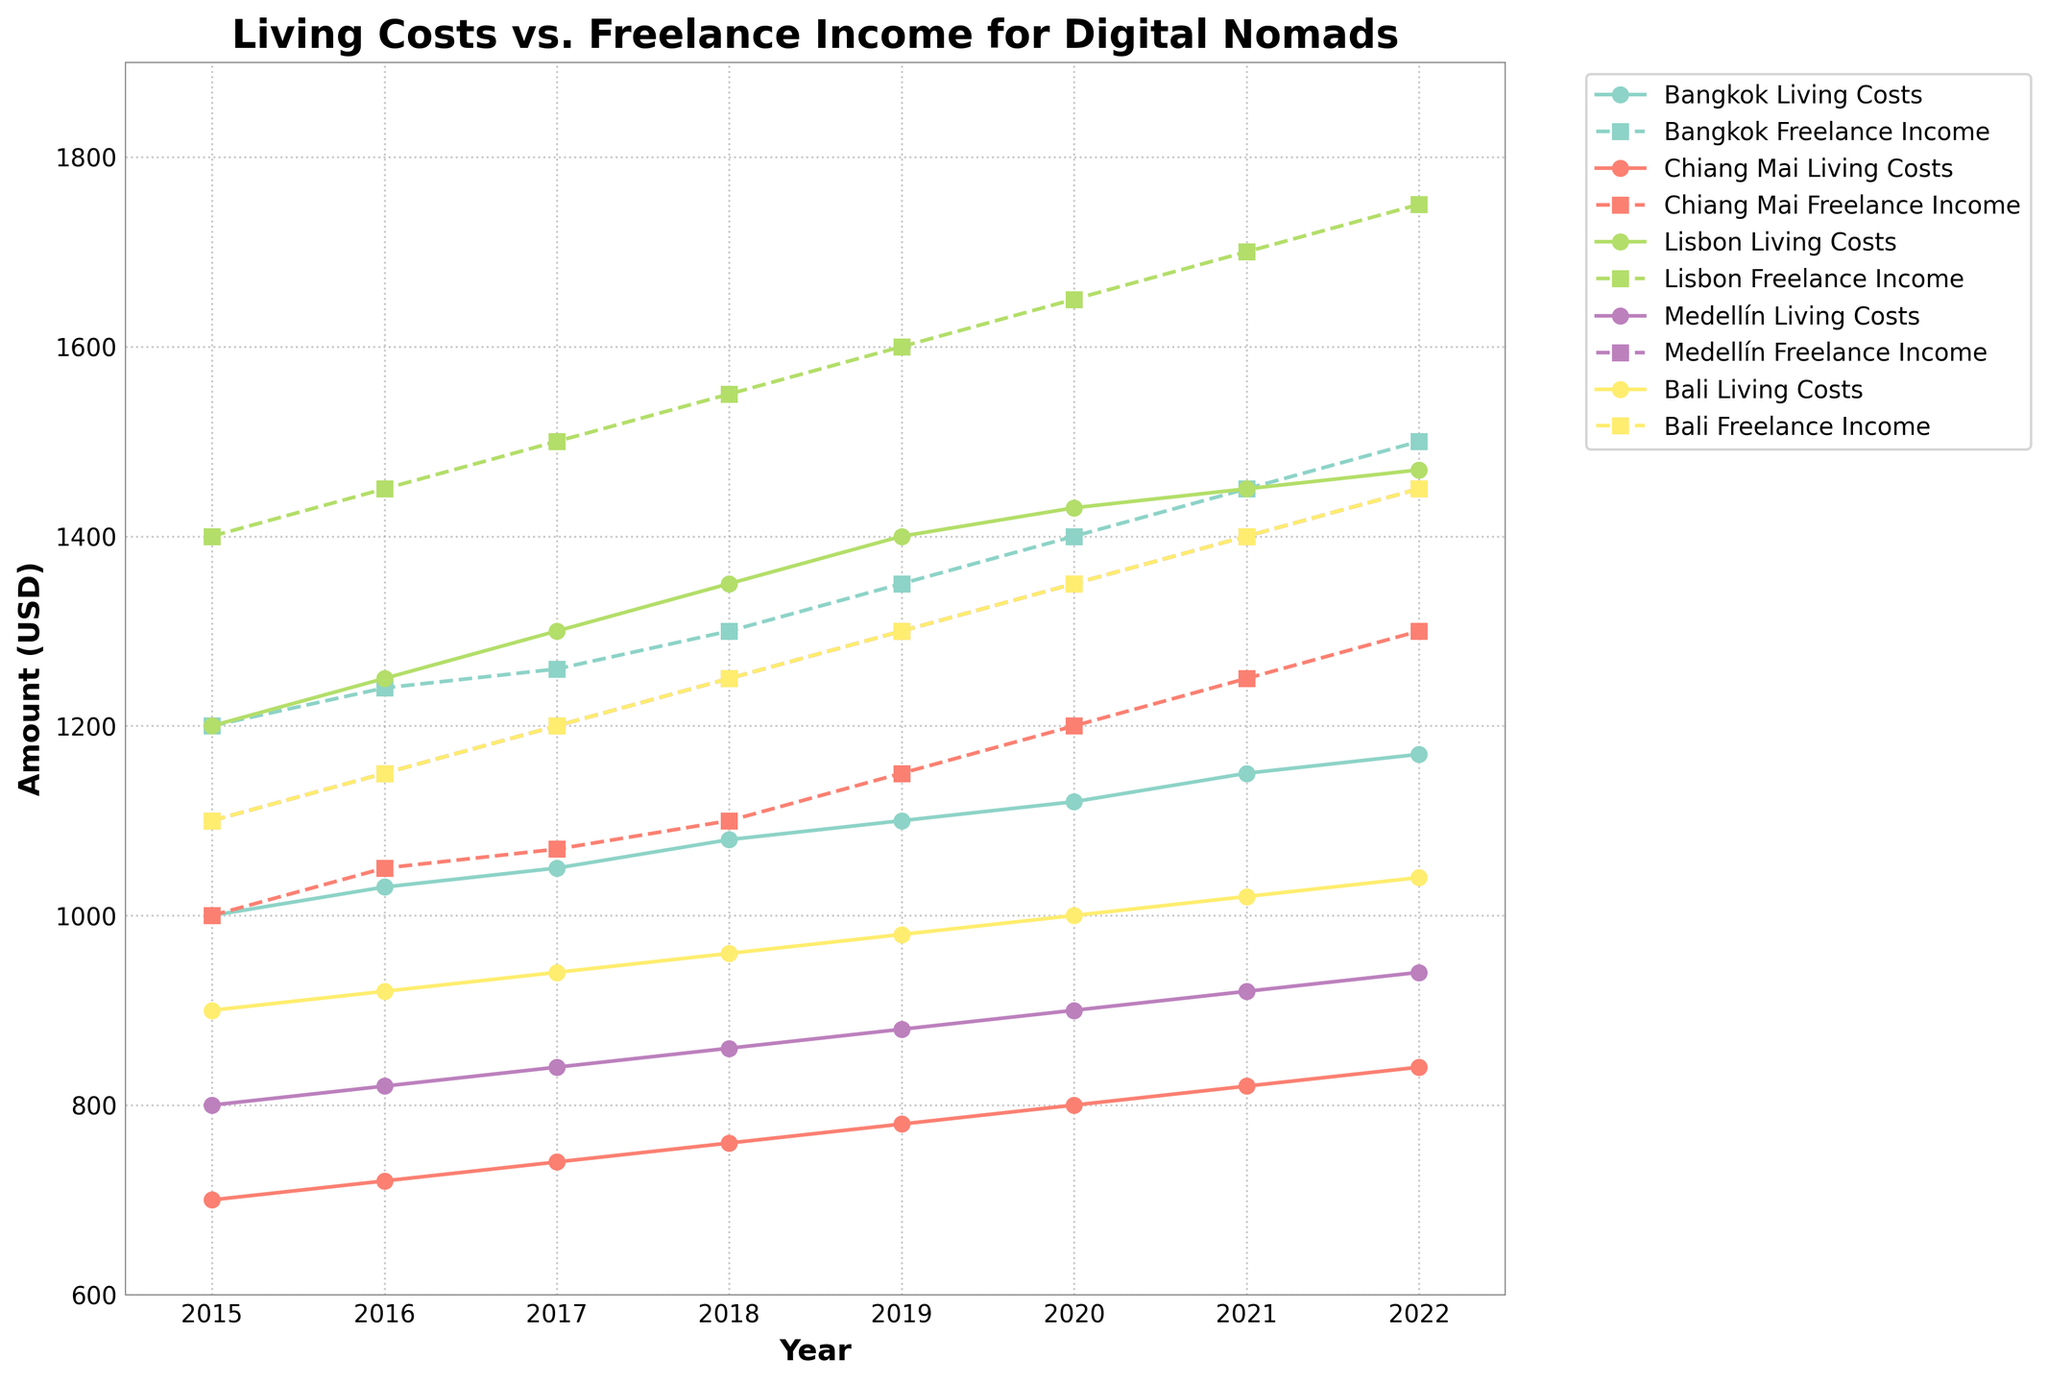What is the title of the figure? The title is displayed at the top of the figure. You can read it directly.
Answer: Living Costs vs. Freelance Income for Digital Nomads How many cities are compared in the figure? The colors and labels indicate that each city has its own pair of lines representing living costs and freelance income. Count the unique labels for cities.
Answer: 5 Between Bangkok and Lisbon, which city had a higher living cost in 2020? Locate the data point for 2020 for each city's 'Living Costs' line and compare the values.
Answer: Lisbon Did freelance income for digital nomads increase every year in Chiang Mai from 2015 to 2022? Follow the 'Freelance Income' line for Chiang Mai and check if the value for each subsequent year is higher than the previous year.
Answer: Yes Which city had the smallest difference between living costs and freelance income in 2022? Calculate the difference between living costs and freelance income for each city in 2022 and find the minimum value.
Answer: Lisbon What is the average living cost in Bali over the period shown in the figure? Sum the living cost values for Bali from 2015 to 2022 and divide by the number of years.
Answer: 945 Which city had the greatest increase in freelance income from 2015 to 2022? For each city, subtract the 2015 freelance income from the 2022 freelance income and identify the largest difference.
Answer: Lisbon Is there any city where the living cost exceeded freelance income in any year? For each city and year, compare living costs to freelance income to see if living costs were higher at any point.
Answer: No Which city had the highest freelance income in 2021? Identify the freelance income values for all cities in 2021 and find the highest value.
Answer: Lisbon Between 2019 and 2020, which city had the least increase in living costs? For each city, subtract the 2019 living cost from the 2020 living cost and find the smallest difference.
Answer: Lisbon 